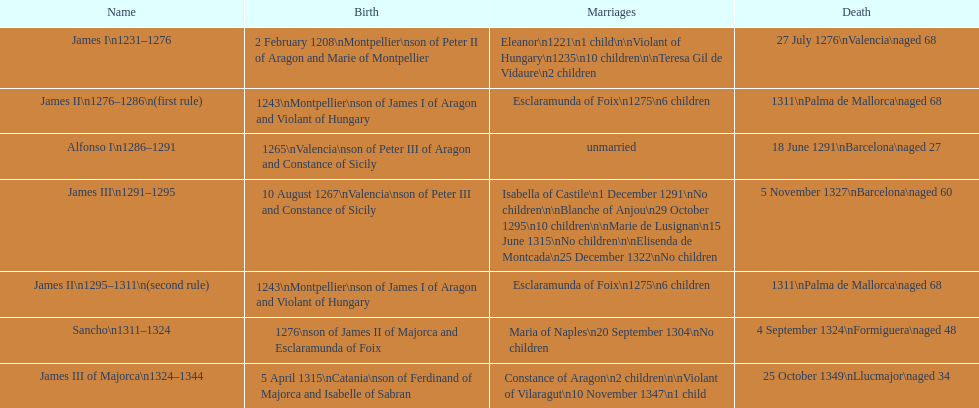James i and james ii both died at what age? 68. 